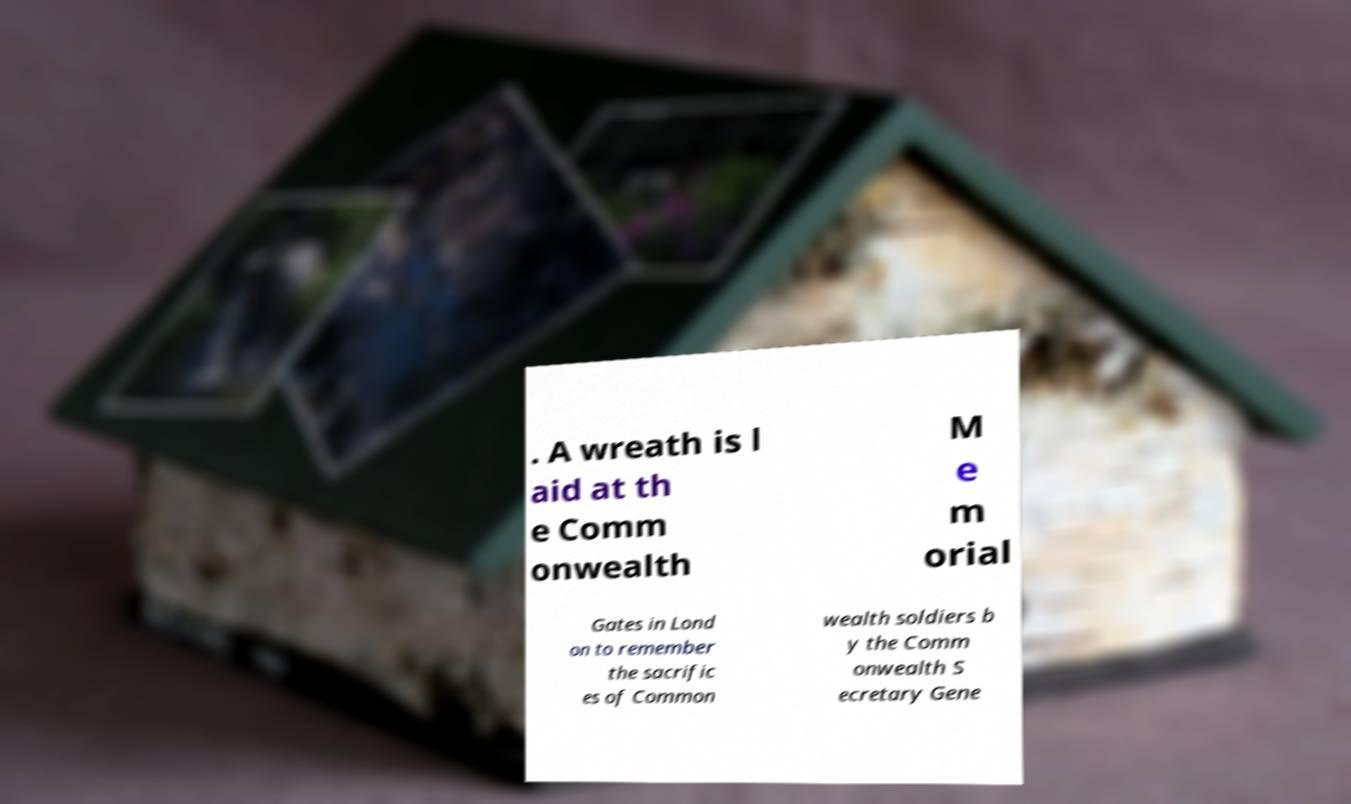Could you extract and type out the text from this image? . A wreath is l aid at th e Comm onwealth M e m orial Gates in Lond on to remember the sacrific es of Common wealth soldiers b y the Comm onwealth S ecretary Gene 